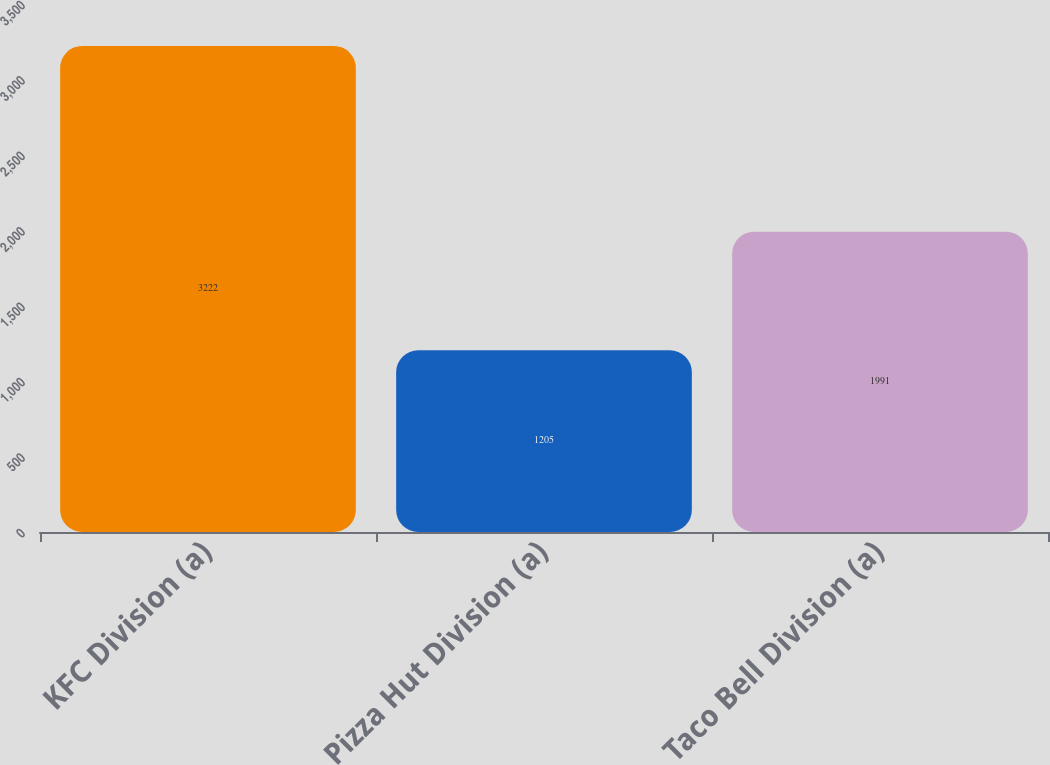<chart> <loc_0><loc_0><loc_500><loc_500><bar_chart><fcel>KFC Division (a)<fcel>Pizza Hut Division (a)<fcel>Taco Bell Division (a)<nl><fcel>3222<fcel>1205<fcel>1991<nl></chart> 